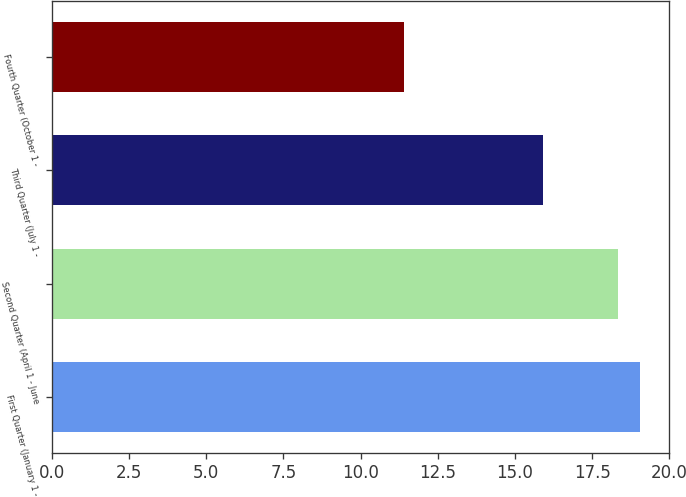<chart> <loc_0><loc_0><loc_500><loc_500><bar_chart><fcel>First Quarter (January 1 -<fcel>Second Quarter (April 1 - June<fcel>Third Quarter (July 1 -<fcel>Fourth Quarter (October 1 -<nl><fcel>19.05<fcel>18.35<fcel>15.92<fcel>11.4<nl></chart> 